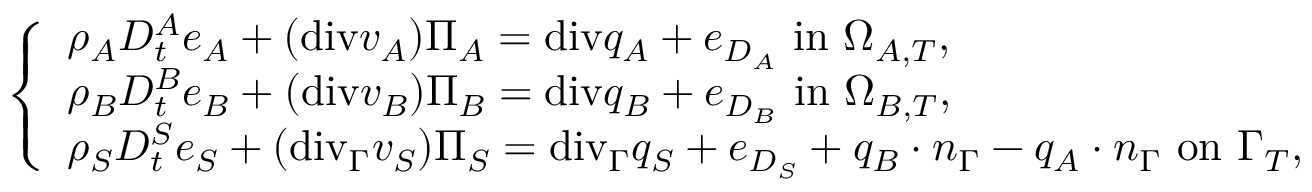<formula> <loc_0><loc_0><loc_500><loc_500>\left \{ \begin{array} { l l } { \rho _ { A } D _ { t } ^ { A } e _ { A } + ( { d i v } v _ { A } ) \Pi _ { A } = { d i v } q _ { A } + e _ { D _ { A } } i n \Omega _ { A , T } , } \\ { \rho _ { B } D _ { t } ^ { B } e _ { B } + ( { d i v } v _ { B } ) \Pi _ { B } = { d i v } q _ { B } + e _ { D _ { B } } i n \Omega _ { B , T } , } \\ { \rho _ { S } D _ { t } ^ { S } e _ { S } + ( { d i v } _ { \Gamma } v _ { S } ) \Pi _ { S } = { d i v } _ { \Gamma } q _ { S } + e _ { D _ { S } } + q _ { B } \cdot n _ { \Gamma } - q _ { A } \cdot n _ { \Gamma } o n \Gamma _ { T } , } \end{array}</formula> 